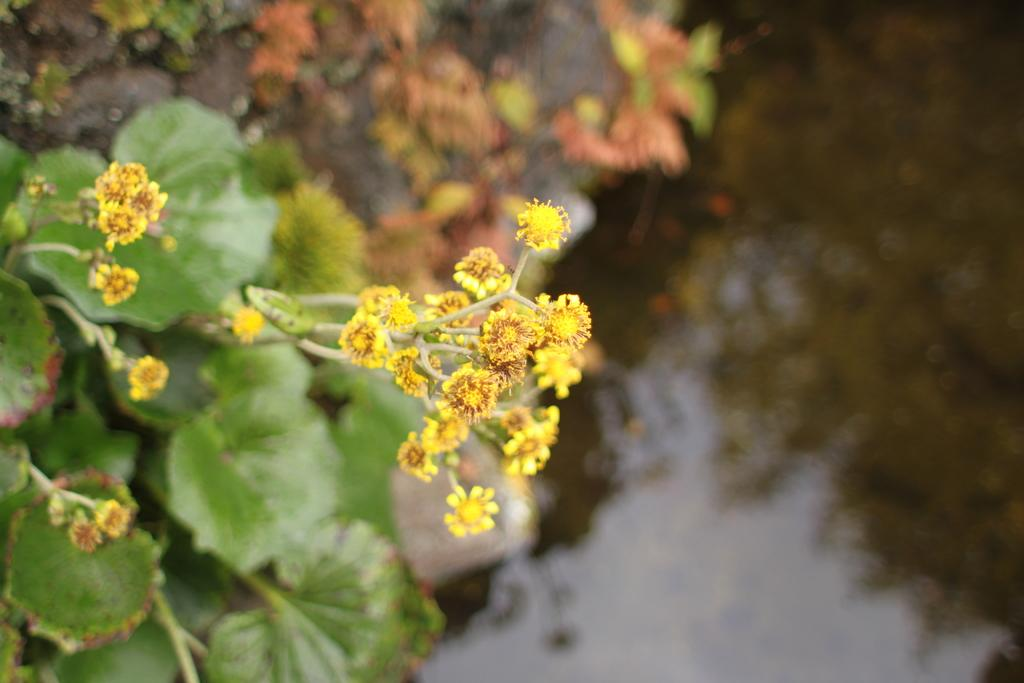What type of plant is in the image? There is a yellow flower plant in the image. Where is the plant located in the image? The flower plant is in the front of the image. What can be observed about the background of the image? The background of the image is blurred. How many kittens are playing with the jar near the sink in the image? There are no kittens, jars, or sinks present in the image. 